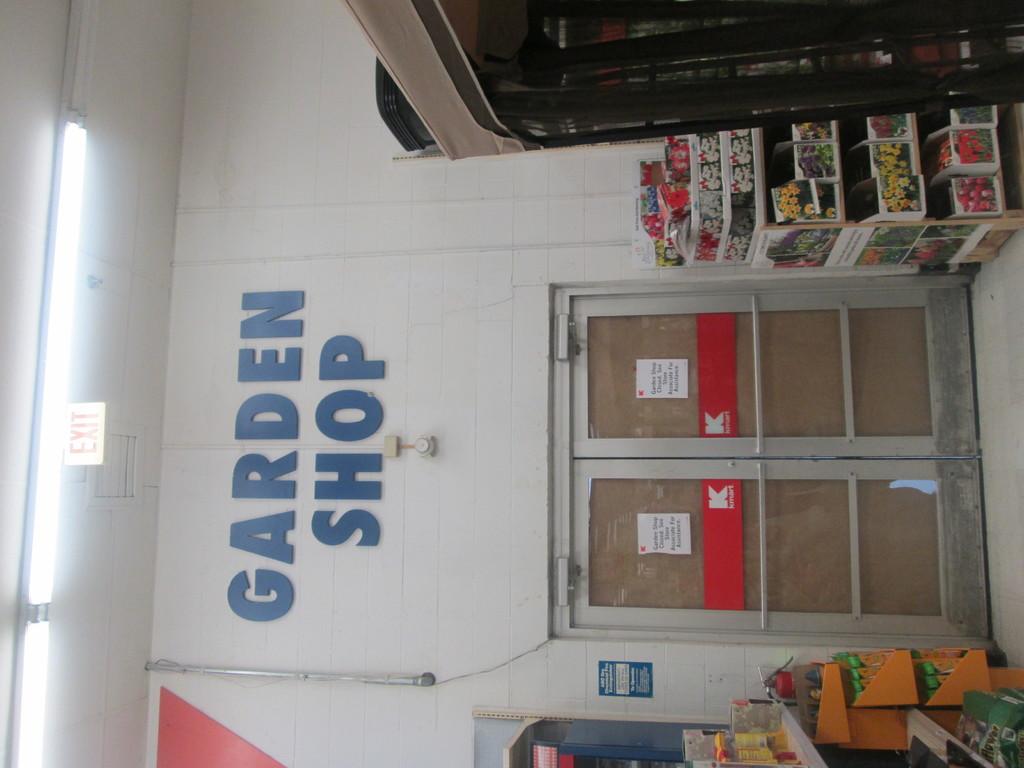What kind of shop is this?
Offer a very short reply. Garden. What kind of shop is this?
Provide a succinct answer. Garden. 